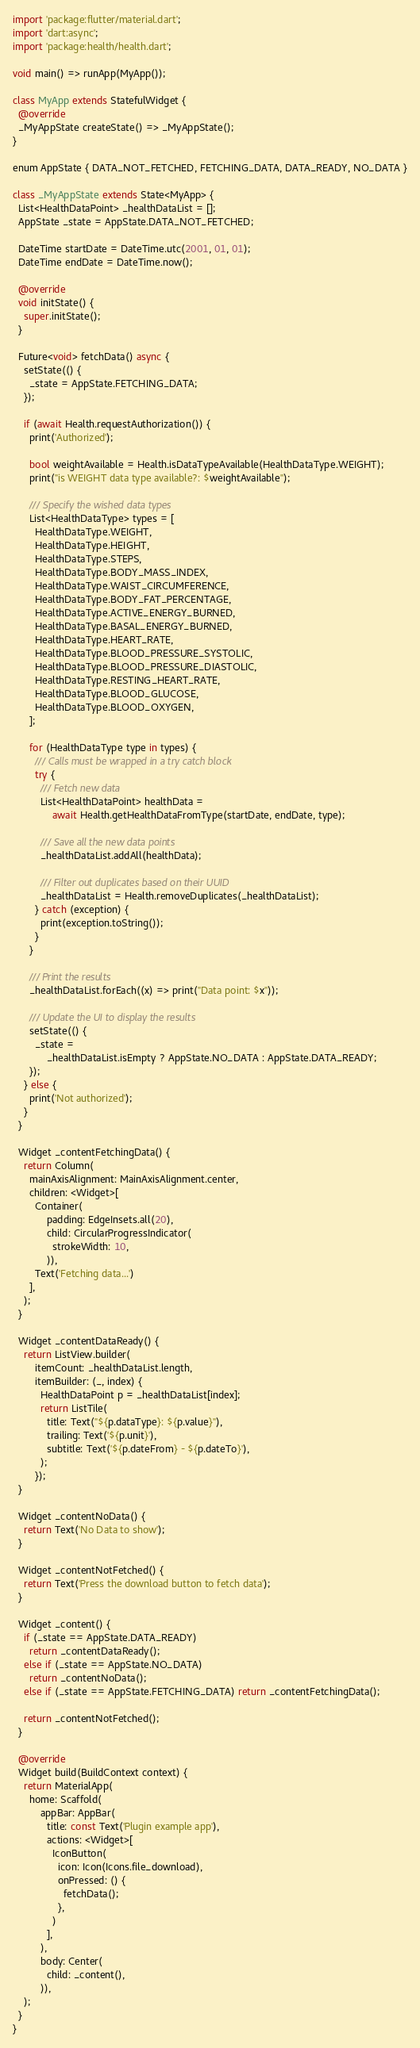<code> <loc_0><loc_0><loc_500><loc_500><_Dart_>import 'package:flutter/material.dart';
import 'dart:async';
import 'package:health/health.dart';

void main() => runApp(MyApp());

class MyApp extends StatefulWidget {
  @override
  _MyAppState createState() => _MyAppState();
}

enum AppState { DATA_NOT_FETCHED, FETCHING_DATA, DATA_READY, NO_DATA }

class _MyAppState extends State<MyApp> {
  List<HealthDataPoint> _healthDataList = [];
  AppState _state = AppState.DATA_NOT_FETCHED;

  DateTime startDate = DateTime.utc(2001, 01, 01);
  DateTime endDate = DateTime.now();

  @override
  void initState() {
    super.initState();
  }

  Future<void> fetchData() async {
    setState(() {
      _state = AppState.FETCHING_DATA;
    });

    if (await Health.requestAuthorization()) {
      print('Authorized');

      bool weightAvailable = Health.isDataTypeAvailable(HealthDataType.WEIGHT);
      print("is WEIGHT data type available?: $weightAvailable");

      /// Specify the wished data types
      List<HealthDataType> types = [
        HealthDataType.WEIGHT,
        HealthDataType.HEIGHT,
        HealthDataType.STEPS,
        HealthDataType.BODY_MASS_INDEX,
        HealthDataType.WAIST_CIRCUMFERENCE,
        HealthDataType.BODY_FAT_PERCENTAGE,
        HealthDataType.ACTIVE_ENERGY_BURNED,
        HealthDataType.BASAL_ENERGY_BURNED,
        HealthDataType.HEART_RATE,
        HealthDataType.BLOOD_PRESSURE_SYSTOLIC,
        HealthDataType.BLOOD_PRESSURE_DIASTOLIC,
        HealthDataType.RESTING_HEART_RATE,
        HealthDataType.BLOOD_GLUCOSE,
        HealthDataType.BLOOD_OXYGEN,
      ];

      for (HealthDataType type in types) {
        /// Calls must be wrapped in a try catch block
        try {
          /// Fetch new data
          List<HealthDataPoint> healthData =
              await Health.getHealthDataFromType(startDate, endDate, type);

          /// Save all the new data points
          _healthDataList.addAll(healthData);

          /// Filter out duplicates based on their UUID
          _healthDataList = Health.removeDuplicates(_healthDataList);
        } catch (exception) {
          print(exception.toString());
        }
      }

      /// Print the results
      _healthDataList.forEach((x) => print("Data point: $x"));

      /// Update the UI to display the results
      setState(() {
        _state =
            _healthDataList.isEmpty ? AppState.NO_DATA : AppState.DATA_READY;
      });
    } else {
      print('Not authorized');
    }
  }

  Widget _contentFetchingData() {
    return Column(
      mainAxisAlignment: MainAxisAlignment.center,
      children: <Widget>[
        Container(
            padding: EdgeInsets.all(20),
            child: CircularProgressIndicator(
              strokeWidth: 10,
            )),
        Text('Fetching data...')
      ],
    );
  }

  Widget _contentDataReady() {
    return ListView.builder(
        itemCount: _healthDataList.length,
        itemBuilder: (_, index) {
          HealthDataPoint p = _healthDataList[index];
          return ListTile(
            title: Text("${p.dataType}: ${p.value}"),
            trailing: Text('${p.unit}'),
            subtitle: Text('${p.dateFrom} - ${p.dateTo}'),
          );
        });
  }

  Widget _contentNoData() {
    return Text('No Data to show');
  }

  Widget _contentNotFetched() {
    return Text('Press the download button to fetch data');
  }

  Widget _content() {
    if (_state == AppState.DATA_READY)
      return _contentDataReady();
    else if (_state == AppState.NO_DATA)
      return _contentNoData();
    else if (_state == AppState.FETCHING_DATA) return _contentFetchingData();

    return _contentNotFetched();
  }

  @override
  Widget build(BuildContext context) {
    return MaterialApp(
      home: Scaffold(
          appBar: AppBar(
            title: const Text('Plugin example app'),
            actions: <Widget>[
              IconButton(
                icon: Icon(Icons.file_download),
                onPressed: () {
                  fetchData();
                },
              )
            ],
          ),
          body: Center(
            child: _content(),
          )),
    );
  }
}
</code> 